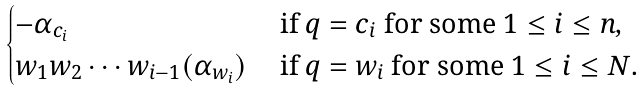Convert formula to latex. <formula><loc_0><loc_0><loc_500><loc_500>\begin{cases} - \alpha _ { c _ { i } } & \text { if } q = c _ { i } \text { for some } 1 \leq i \leq n , \\ w _ { 1 } w _ { 2 } \cdots w _ { i - 1 } ( \alpha _ { w _ { i } } ) & \text { if } q = w _ { i } \text { for some } 1 \leq i \leq N . \end{cases}</formula> 